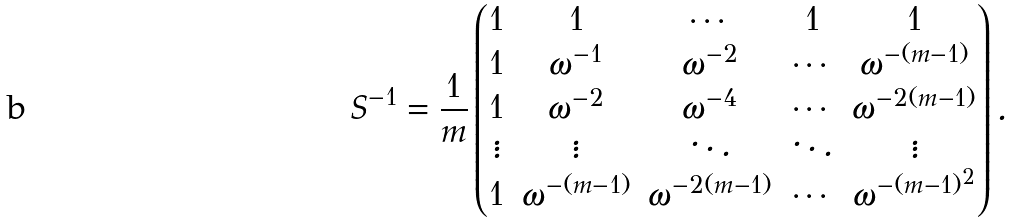<formula> <loc_0><loc_0><loc_500><loc_500>S ^ { - 1 } = \frac { 1 } { m } \begin{pmatrix} 1 & 1 & \cdots & 1 & 1 \\ 1 & \omega ^ { - 1 } & \omega ^ { - 2 } & \cdots & \omega ^ { - ( m - 1 ) } \\ 1 & \omega ^ { - 2 } & \omega ^ { - 4 } & \cdots & \omega ^ { - 2 ( m - 1 ) } \\ \vdots & \vdots & \ddots & \ddots & \vdots \\ 1 & \omega ^ { - ( m - 1 ) } & \omega ^ { - 2 ( m - 1 ) } & \cdots & \omega ^ { - ( m - 1 ) ^ { 2 } } \end{pmatrix} .</formula> 